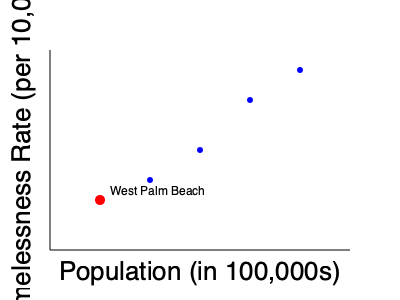Based on the scatter plot comparing homelessness rates and population sizes in Florida cities, how does West Palm Beach's homelessness rate compare to other cities of similar or larger size? To answer this question, we need to analyze the scatter plot:

1. Identify West Palm Beach: It's represented by the red dot on the plot.

2. Interpret the axes:
   - X-axis represents population in 100,000s
   - Y-axis represents homelessness rate per 10,000 people

3. Observe West Palm Beach's position:
   - It has a relatively small population (around 1-1.5 hundred thousand)
   - Its homelessness rate is higher on the Y-axis compared to other cities

4. Compare to other cities:
   - Blue dots represent other Florida cities
   - Cities to the right have larger populations
   - Cities higher on the Y-axis have higher homelessness rates

5. Analyze the trend:
   - Most cities with larger populations (further right) have lower homelessness rates (lower on Y-axis)
   - West Palm Beach has a higher homelessness rate than all other cities shown, including those with larger populations

Therefore, West Palm Beach's homelessness rate is higher compared to other Florida cities of similar or larger size.
Answer: Higher than other cities 